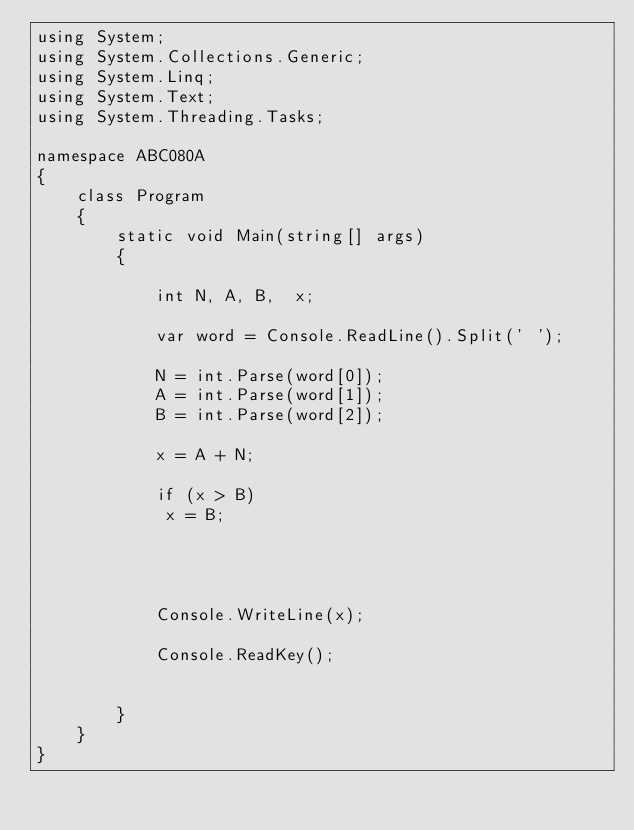Convert code to text. <code><loc_0><loc_0><loc_500><loc_500><_C#_>using System;
using System.Collections.Generic;
using System.Linq;
using System.Text;
using System.Threading.Tasks;

namespace ABC080A
{
    class Program
    {
        static void Main(string[] args)
        {

            int N, A, B,  x;

            var word = Console.ReadLine().Split(' ');

            N = int.Parse(word[0]);
            A = int.Parse(word[1]);
            B = int.Parse(word[2]);

            x = A + N;

            if (x > B) 
             x = B;




            Console.WriteLine(x);

            Console.ReadKey();


        }
    }
}
</code> 